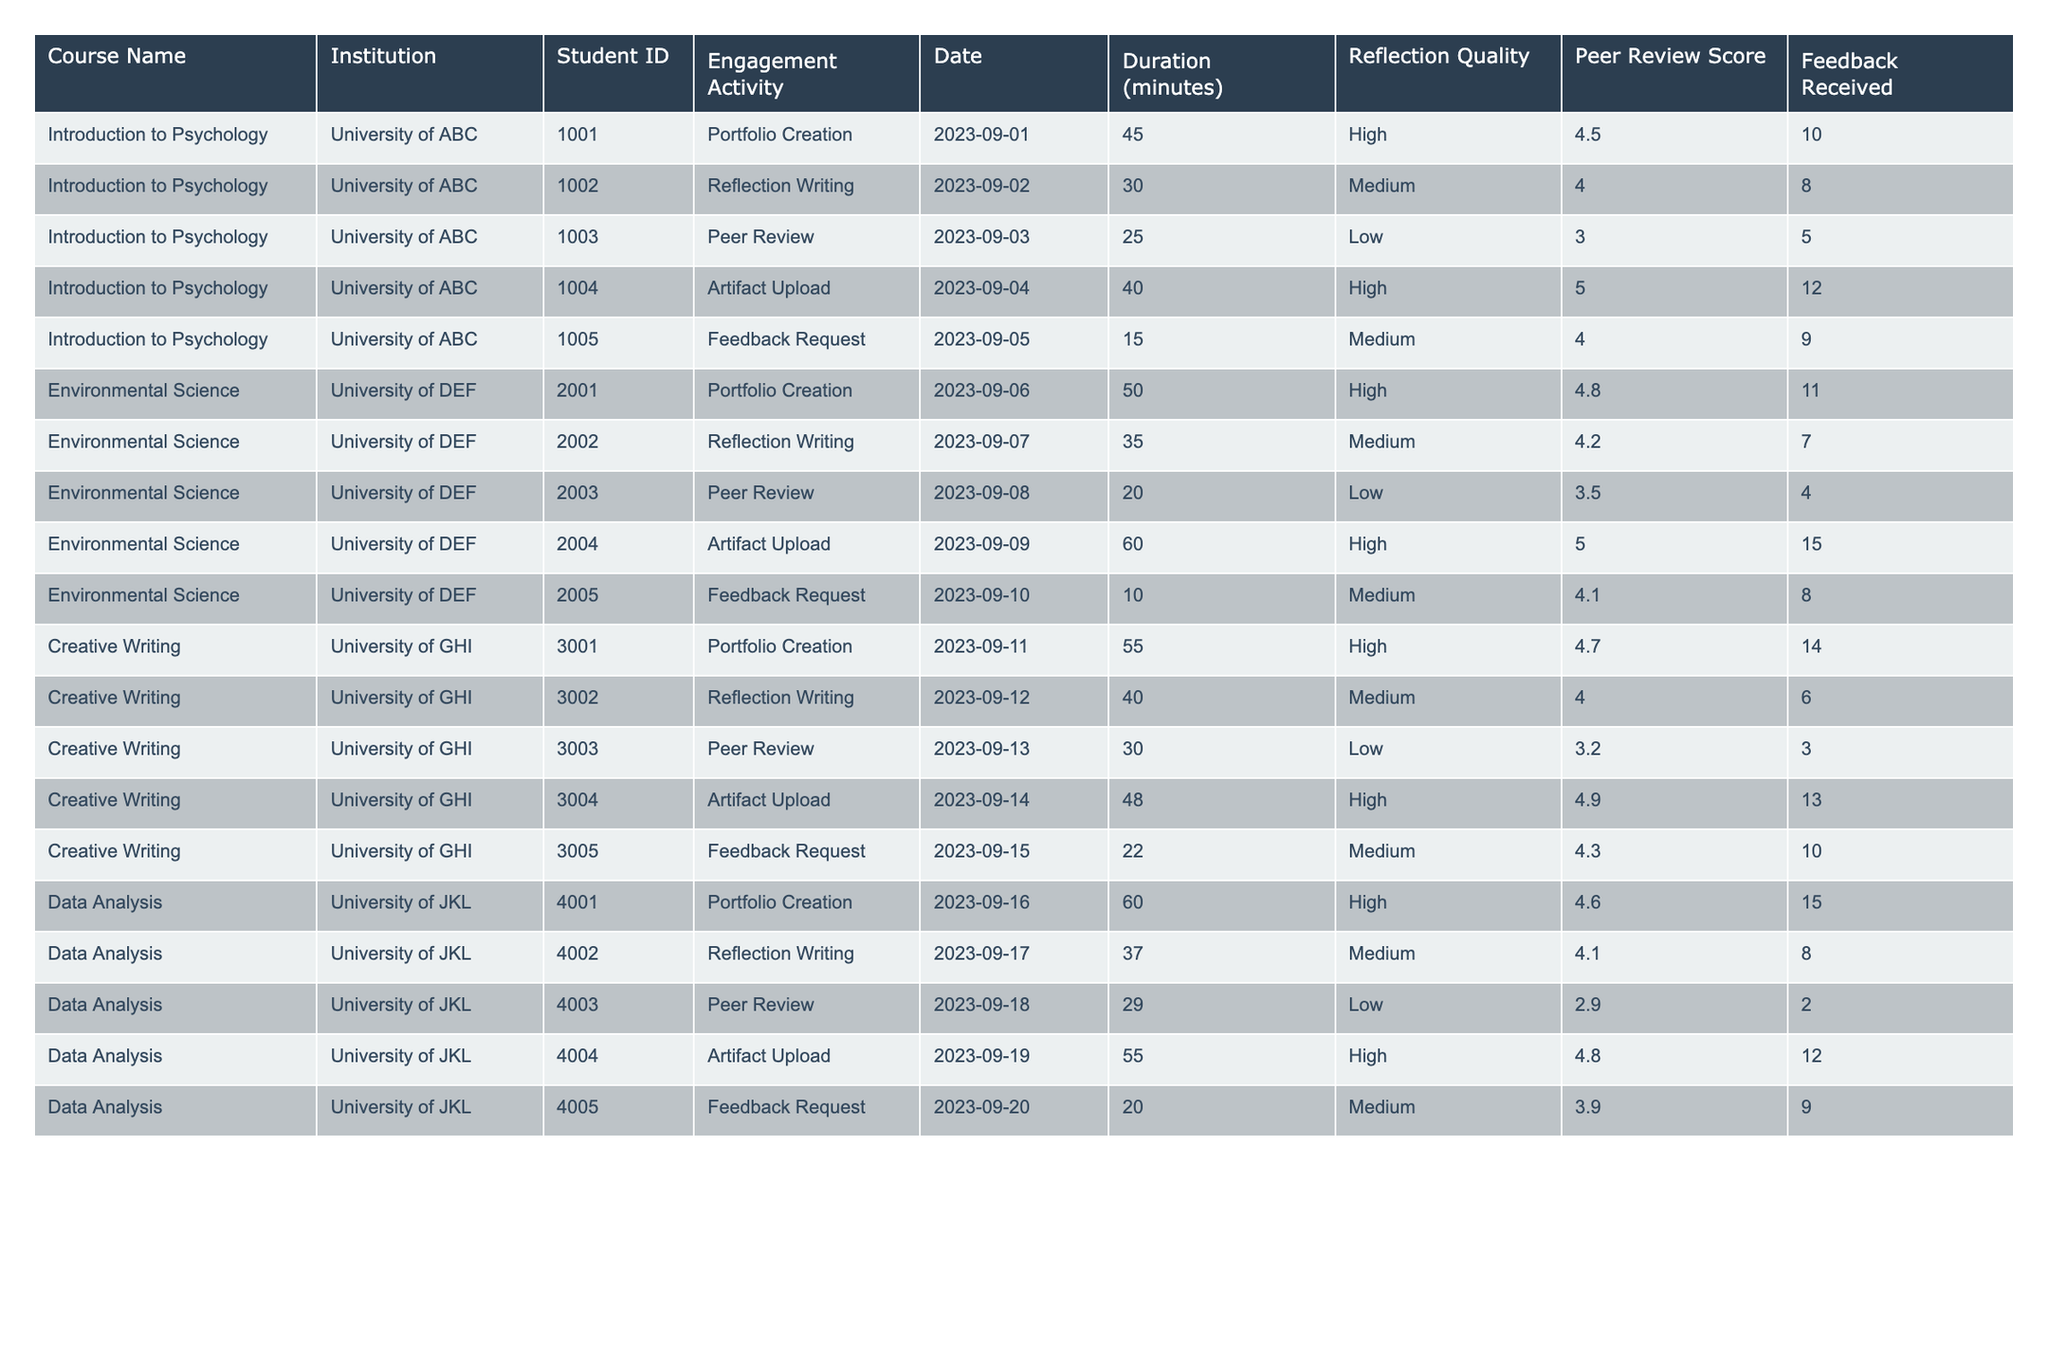What is the total engagement duration for the course "Creative Writing"? By checking the "Duration (minutes)" column for the "Creative Writing" course, we find the engagement durations are 55, 40, 30, 48, and 22 minutes. Adding these together gives us: 55 + 40 + 30 + 48 + 22 = 195.
Answer: 195 Which course received the highest peer review score and what was the score? We look through the "Peer Review Score" column across all courses. The highest score is found in "Environmental Science" with a score of 5.0.
Answer: Environmental Science, 5.0 How many total pieces of feedback were received across all courses? Summing the "Feedback Received" column: 10 + 8 + 5 + 12 + 9 + 11 + 7 + 4 + 15 + 8 + 14 + 6 + 3 + 13 + 10 + 15 + 8 + 2 + 12 + 9 = 186.
Answer: 186 Is there a course in which all engagement activities have high reflection quality? Reviewing the "Reflection Quality" column, we see both "Introduction to Psychology" and "Environmental Science" have low reflection quality for peer reviews, so no course has all high reflection quality.
Answer: No What is the average peer review score for the "Data Analysis" course? Summing the peer review scores in the "Data Analysis" course: 4.6, 4.1, 2.9, 4.8, 3.9 gives us 4.6 + 4.1 + 2.9 + 4.8 + 3.9 = 20.3. Dividing by the number of entries (5) gives us 20.3 / 5 = 4.06.
Answer: 4.06 Which student had the lowest engagement duration and what was the activity? Looking at the "Duration (minutes)" column, the lowest duration is found for Student ID 2005 in the "Environmental Science" course with 10 minutes for "Feedback Request."
Answer: Student ID 2005, Feedback Request, 10 minutes How many total high reflection quality activities were recorded across all courses? Reviewing the "Reflection Quality" column, counting the instances marked as "High," we find there are 8 such activities across the courses.
Answer: 8 What is the total amount of peer review scores for the course "Introduction to Psychology"? The peer review scores for "Introduction to Psychology" are 4.5, 4.0, 3.0, 5.0, and 4.0. Summing these gives 4.5 + 4.0 + 3.0 + 5.0 + 4.0 = 20.5.
Answer: 20.5 Which course had the longest engagement activity and how long was it? Observing the "Duration (minutes)" column, the longest duration is found in "Environmental Science" with 60 minutes for "Artifact Upload."
Answer: Environmental Science, 60 minutes How does the average feedback received for "Creative Writing" compare to that of "Data Analysis"? The average feedback received for "Creative Writing" is (14 + 6 + 3 + 13 + 10) / 5 = 9.2. For "Data Analysis," it is (15 + 8 + 2 + 12 + 9) / 5 = 9.2. Both averages are equal.
Answer: They are equal, 9.2 each 